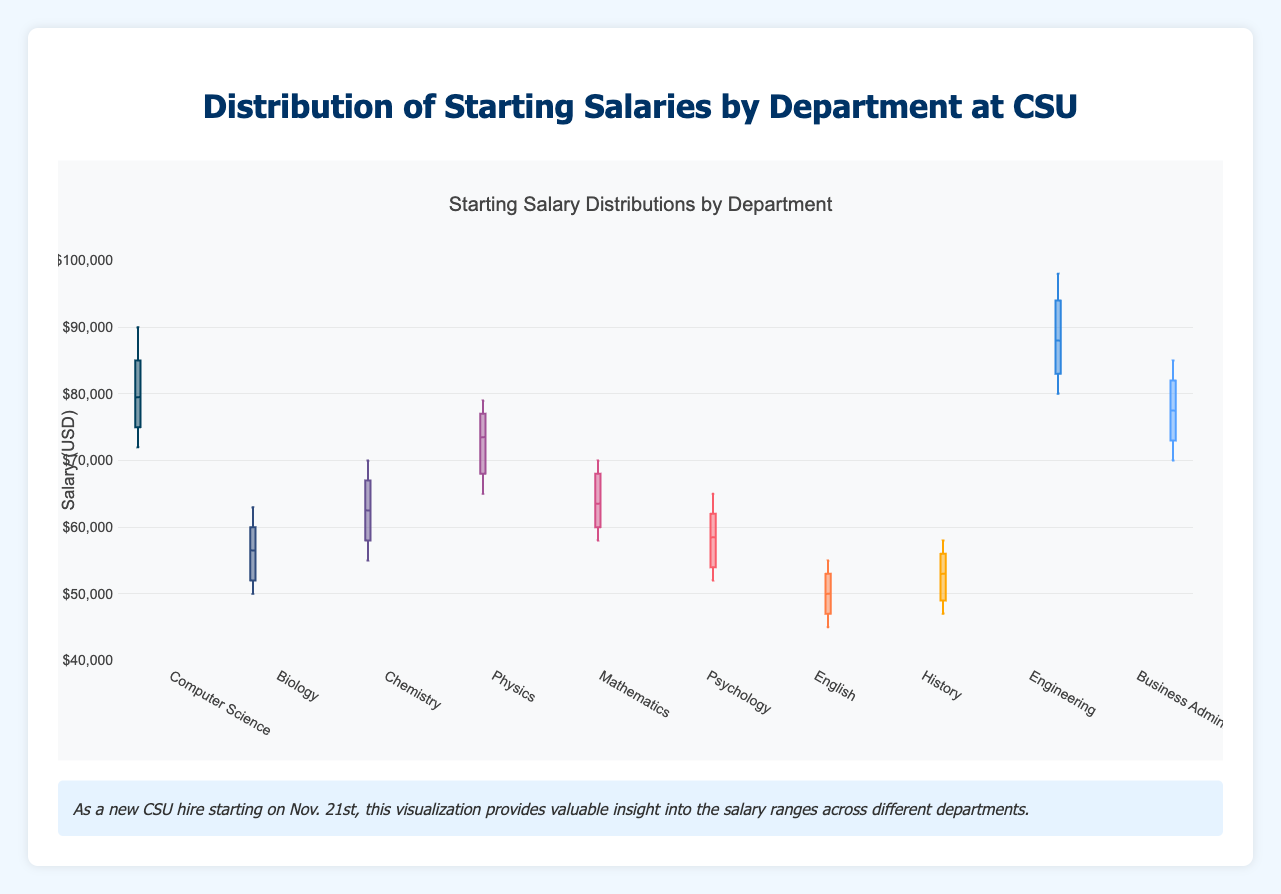What is the title of the figure? The title is usually found at the top of the figure. In this case, it states, “Starting Salary Distributions by Department.”
Answer: Starting Salary Distributions by Department Which department has the highest starting salary outliers? By observing the box plots, we look for points that are outside the whiskers of any box. The "Engineering" department has the highest suspected outliers.
Answer: Engineering What is the median starting salary for the Chemistry department? The median is represented by the line inside the box of the Chemistry department's box plot. It is approximately $61,000.
Answer: $61,000 Which department has the widest range of starting salaries? The range is the difference between the highest and lowest points within the whiskers. The "Engineering" department has a wide range from around $80,000 to $98,000.
Answer: Engineering Which department has the lowest median starting salary? By comparing the lines inside each box plot, we see that the "English" department has the lowest median salary, which is around $50,000.
Answer: English Compare the median starting salaries of the Physics and Mathematics departments. Which one is higher and by how much? The median starting salary for Physics is about $73,000, and for Mathematics, it is about $64,000. The Physics department's median salary is higher by $9,000.
Answer: Physics by $9,000 What is the interquartile range (IQR) for the Business Administration department? The IQR is calculated by subtracting the first quartile (Q1) from the third quartile (Q3). For Business Administration, Q3 is about $85,000 and Q1 is about $73,000. Thus, IQR = $85,000 - $73,000 = $12,000.
Answer: $12,000 Which department's boxplot is centered closer to $60,000? The "Biology" department has its median around $60,000.
Answer: Biology Which two departments have the closest median starting salaries? By examining the medians, "Chemistry" and "Mathematics" have medians very close to each other, both around approximately $64,000 and $63,000 respectively.
Answer: Chemistry and Mathematics Is there any department with no suspected outliers in starting salaries? Observing the box plots shows that the "Psychology" department does not display any points outside the whiskers, indicating no suspected outliers.
Answer: Psychology 